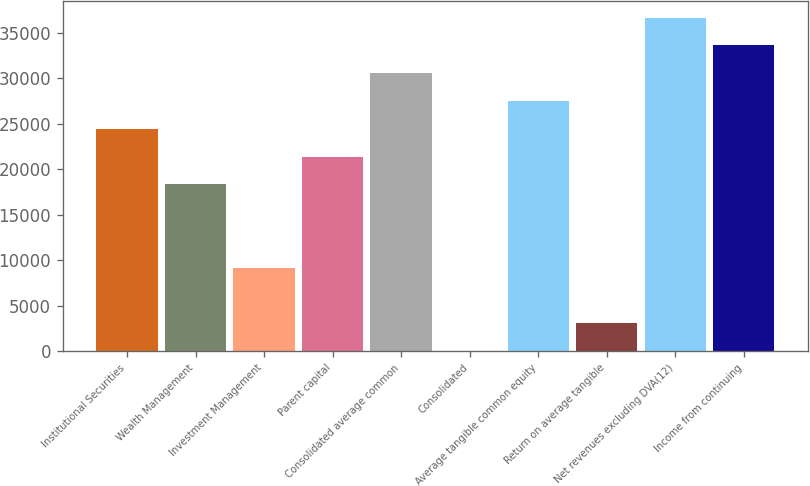Convert chart. <chart><loc_0><loc_0><loc_500><loc_500><bar_chart><fcel>Institutional Securities<fcel>Wealth Management<fcel>Investment Management<fcel>Parent capital<fcel>Consolidated average common<fcel>Consolidated<fcel>Average tangible common equity<fcel>Return on average tangible<fcel>Net revenues excluding DVA(12)<fcel>Income from continuing<nl><fcel>24464<fcel>18348<fcel>9174.07<fcel>21406<fcel>30580<fcel>0.1<fcel>27522<fcel>3058.09<fcel>36696<fcel>33638<nl></chart> 